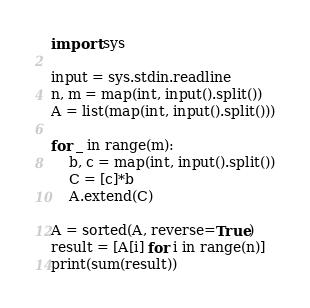<code> <loc_0><loc_0><loc_500><loc_500><_Python_>import sys

input = sys.stdin.readline
n, m = map(int, input().split())
A = list(map(int, input().split()))

for _ in range(m):
    b, c = map(int, input().split())
    C = [c]*b
    A.extend(C)

A = sorted(A, reverse=True)
result = [A[i] for i in range(n)]
print(sum(result))</code> 